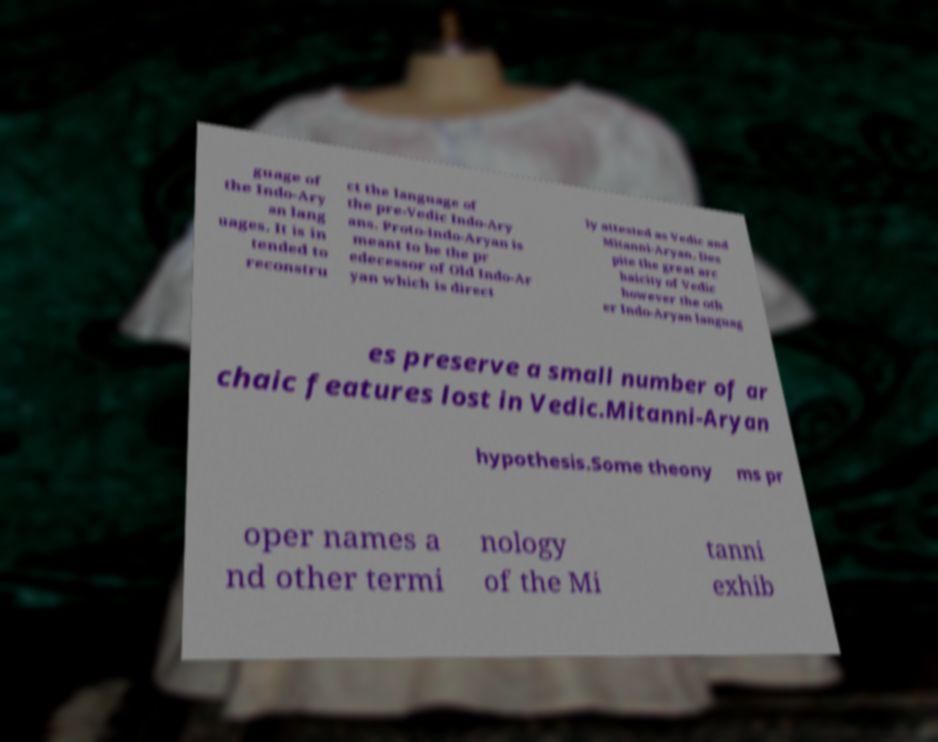Please identify and transcribe the text found in this image. guage of the Indo-Ary an lang uages. It is in tended to reconstru ct the language of the pre-Vedic Indo-Ary ans. Proto-Indo-Aryan is meant to be the pr edecessor of Old Indo-Ar yan which is direct ly attested as Vedic and Mitanni-Aryan. Des pite the great arc haicity of Vedic however the oth er Indo-Aryan languag es preserve a small number of ar chaic features lost in Vedic.Mitanni-Aryan hypothesis.Some theony ms pr oper names a nd other termi nology of the Mi tanni exhib 